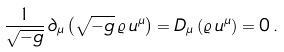Convert formula to latex. <formula><loc_0><loc_0><loc_500><loc_500>\frac { 1 } { \sqrt { - g } } \, \partial _ { \mu } \left ( \sqrt { - g } \, \varrho \, u ^ { \mu } \right ) = D _ { \mu } \left ( \varrho \, u ^ { \mu } \right ) = 0 \, .</formula> 